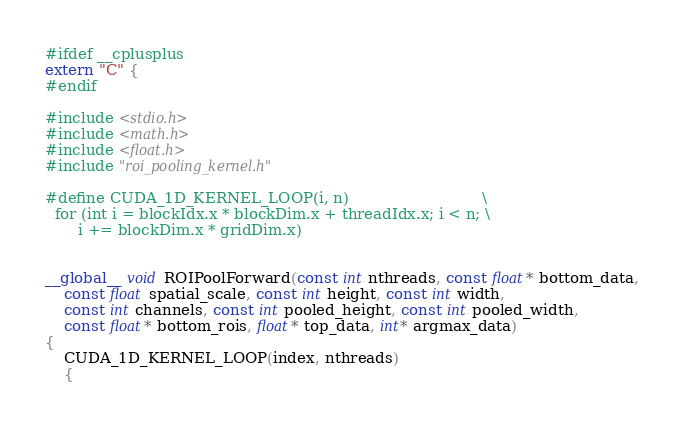Convert code to text. <code><loc_0><loc_0><loc_500><loc_500><_Cuda_>#ifdef __cplusplus
extern "C" {
#endif

#include <stdio.h>
#include <math.h>
#include <float.h>
#include "roi_pooling_kernel.h"

#define CUDA_1D_KERNEL_LOOP(i, n)                            \
  for (int i = blockIdx.x * blockDim.x + threadIdx.x; i < n; \
       i += blockDim.x * gridDim.x)


__global__ void ROIPoolForward(const int nthreads, const float* bottom_data,
    const float spatial_scale, const int height, const int width,
    const int channels, const int pooled_height, const int pooled_width,
    const float* bottom_rois, float* top_data, int* argmax_data)
{
    CUDA_1D_KERNEL_LOOP(index, nthreads)
    {</code> 